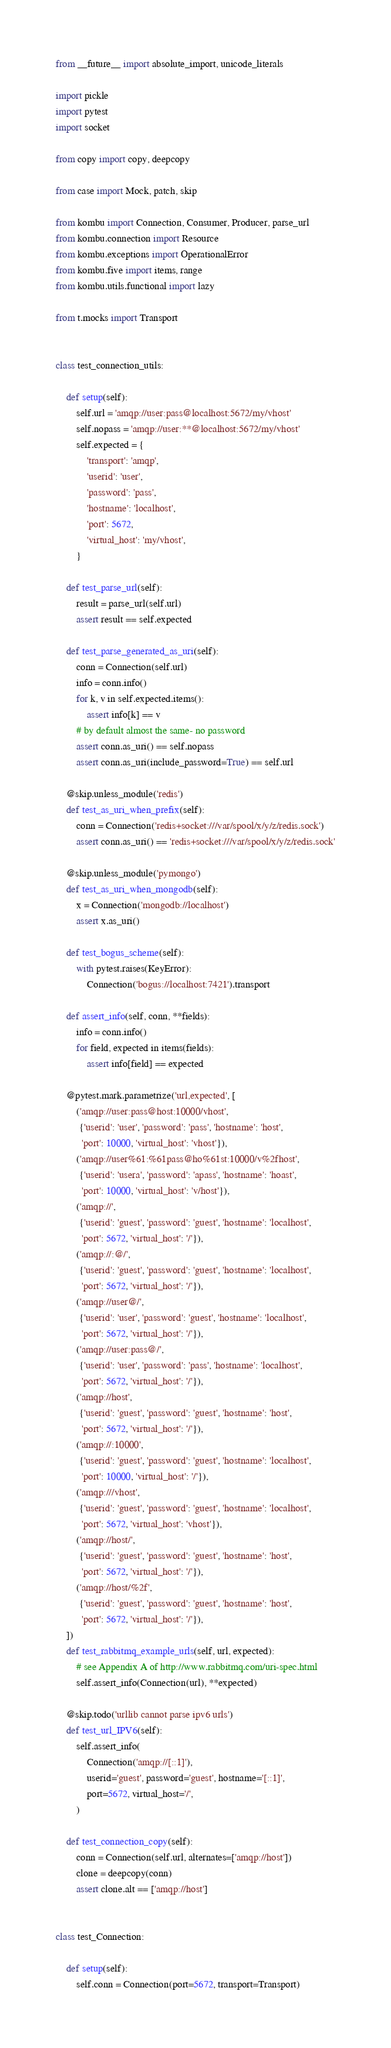Convert code to text. <code><loc_0><loc_0><loc_500><loc_500><_Python_>from __future__ import absolute_import, unicode_literals

import pickle
import pytest
import socket

from copy import copy, deepcopy

from case import Mock, patch, skip

from kombu import Connection, Consumer, Producer, parse_url
from kombu.connection import Resource
from kombu.exceptions import OperationalError
from kombu.five import items, range
from kombu.utils.functional import lazy

from t.mocks import Transport


class test_connection_utils:

    def setup(self):
        self.url = 'amqp://user:pass@localhost:5672/my/vhost'
        self.nopass = 'amqp://user:**@localhost:5672/my/vhost'
        self.expected = {
            'transport': 'amqp',
            'userid': 'user',
            'password': 'pass',
            'hostname': 'localhost',
            'port': 5672,
            'virtual_host': 'my/vhost',
        }

    def test_parse_url(self):
        result = parse_url(self.url)
        assert result == self.expected

    def test_parse_generated_as_uri(self):
        conn = Connection(self.url)
        info = conn.info()
        for k, v in self.expected.items():
            assert info[k] == v
        # by default almost the same- no password
        assert conn.as_uri() == self.nopass
        assert conn.as_uri(include_password=True) == self.url

    @skip.unless_module('redis')
    def test_as_uri_when_prefix(self):
        conn = Connection('redis+socket:///var/spool/x/y/z/redis.sock')
        assert conn.as_uri() == 'redis+socket:///var/spool/x/y/z/redis.sock'

    @skip.unless_module('pymongo')
    def test_as_uri_when_mongodb(self):
        x = Connection('mongodb://localhost')
        assert x.as_uri()

    def test_bogus_scheme(self):
        with pytest.raises(KeyError):
            Connection('bogus://localhost:7421').transport

    def assert_info(self, conn, **fields):
        info = conn.info()
        for field, expected in items(fields):
            assert info[field] == expected

    @pytest.mark.parametrize('url,expected', [
        ('amqp://user:pass@host:10000/vhost',
         {'userid': 'user', 'password': 'pass', 'hostname': 'host',
          'port': 10000, 'virtual_host': 'vhost'}),
        ('amqp://user%61:%61pass@ho%61st:10000/v%2fhost',
         {'userid': 'usera', 'password': 'apass', 'hostname': 'hoast',
          'port': 10000, 'virtual_host': 'v/host'}),
        ('amqp://',
         {'userid': 'guest', 'password': 'guest', 'hostname': 'localhost',
          'port': 5672, 'virtual_host': '/'}),
        ('amqp://:@/',
         {'userid': 'guest', 'password': 'guest', 'hostname': 'localhost',
          'port': 5672, 'virtual_host': '/'}),
        ('amqp://user@/',
         {'userid': 'user', 'password': 'guest', 'hostname': 'localhost',
          'port': 5672, 'virtual_host': '/'}),
        ('amqp://user:pass@/',
         {'userid': 'user', 'password': 'pass', 'hostname': 'localhost',
          'port': 5672, 'virtual_host': '/'}),
        ('amqp://host',
         {'userid': 'guest', 'password': 'guest', 'hostname': 'host',
          'port': 5672, 'virtual_host': '/'}),
        ('amqp://:10000',
         {'userid': 'guest', 'password': 'guest', 'hostname': 'localhost',
          'port': 10000, 'virtual_host': '/'}),
        ('amqp:///vhost',
         {'userid': 'guest', 'password': 'guest', 'hostname': 'localhost',
          'port': 5672, 'virtual_host': 'vhost'}),
        ('amqp://host/',
         {'userid': 'guest', 'password': 'guest', 'hostname': 'host',
          'port': 5672, 'virtual_host': '/'}),
        ('amqp://host/%2f',
         {'userid': 'guest', 'password': 'guest', 'hostname': 'host',
          'port': 5672, 'virtual_host': '/'}),
    ])
    def test_rabbitmq_example_urls(self, url, expected):
        # see Appendix A of http://www.rabbitmq.com/uri-spec.html
        self.assert_info(Connection(url), **expected)

    @skip.todo('urllib cannot parse ipv6 urls')
    def test_url_IPV6(self):
        self.assert_info(
            Connection('amqp://[::1]'),
            userid='guest', password='guest', hostname='[::1]',
            port=5672, virtual_host='/',
        )

    def test_connection_copy(self):
        conn = Connection(self.url, alternates=['amqp://host'])
        clone = deepcopy(conn)
        assert clone.alt == ['amqp://host']


class test_Connection:

    def setup(self):
        self.conn = Connection(port=5672, transport=Transport)
</code> 